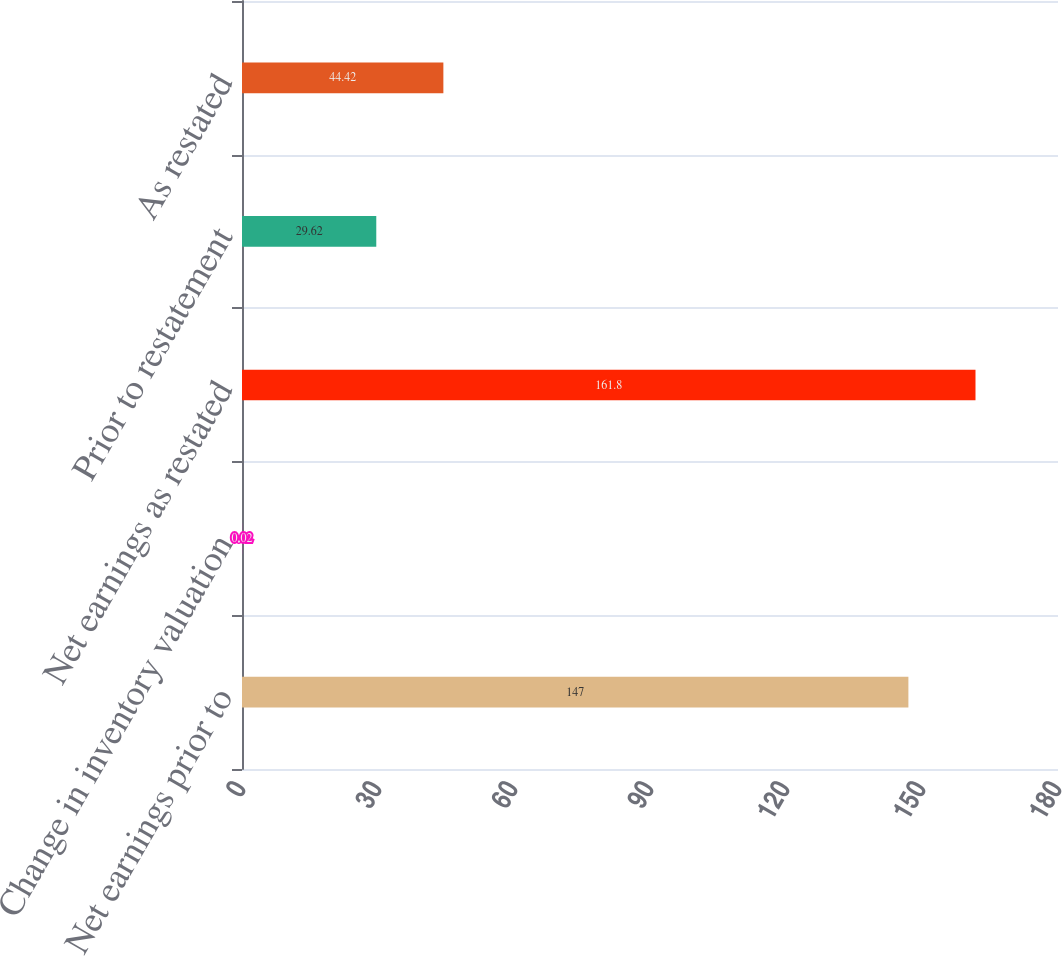Convert chart to OTSL. <chart><loc_0><loc_0><loc_500><loc_500><bar_chart><fcel>Net earnings prior to<fcel>Change in inventory valuation<fcel>Net earnings as restated<fcel>Prior to restatement<fcel>As restated<nl><fcel>147<fcel>0.02<fcel>161.8<fcel>29.62<fcel>44.42<nl></chart> 